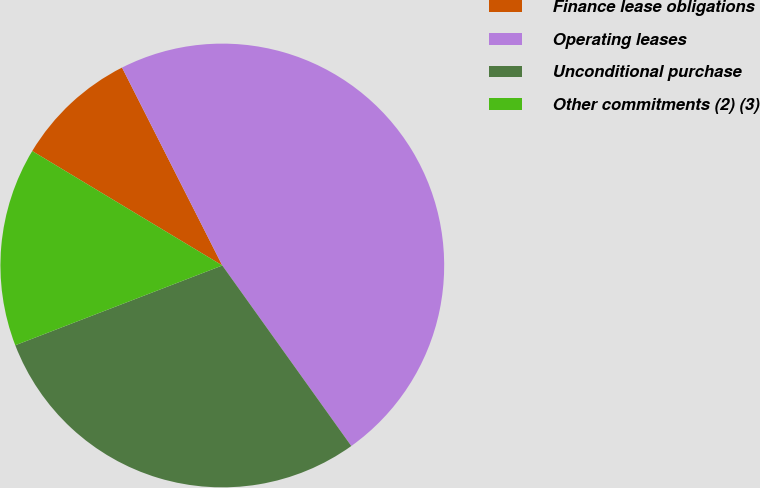<chart> <loc_0><loc_0><loc_500><loc_500><pie_chart><fcel>Finance lease obligations<fcel>Operating leases<fcel>Unconditional purchase<fcel>Other commitments (2) (3)<nl><fcel>8.91%<fcel>47.59%<fcel>29.02%<fcel>14.48%<nl></chart> 